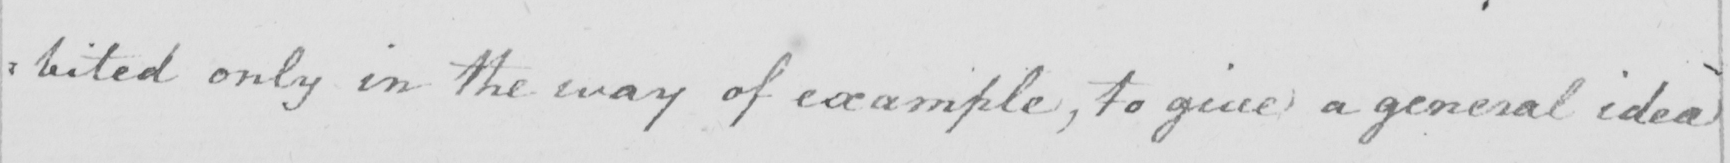Please transcribe the handwritten text in this image. : bited only in the way of example , to give a general idea ) 